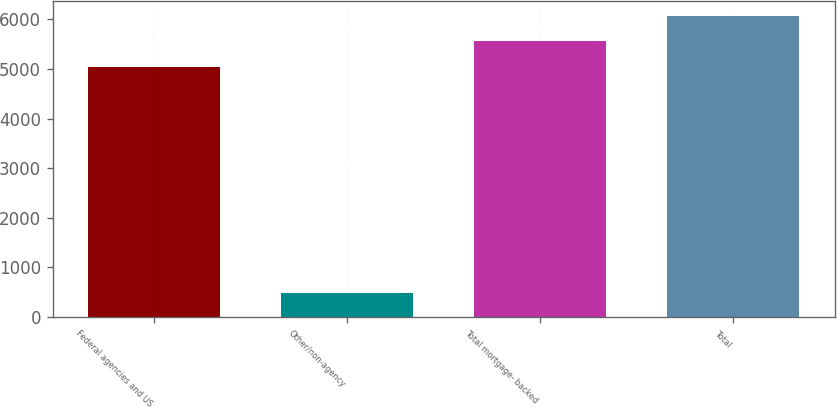Convert chart. <chart><loc_0><loc_0><loc_500><loc_500><bar_chart><fcel>Federal agencies and US<fcel>Other/non-agency<fcel>Total mortgage- backed<fcel>Total<nl><fcel>5048<fcel>477<fcel>5553.8<fcel>6059.6<nl></chart> 